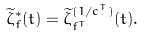Convert formula to latex. <formula><loc_0><loc_0><loc_500><loc_500>\widetilde { \zeta } ^ { \ast } _ { f } ( t ) = \widetilde { \zeta } ^ { ( 1 / c ^ { T } ) } _ { f ^ { T } } ( t ) .</formula> 